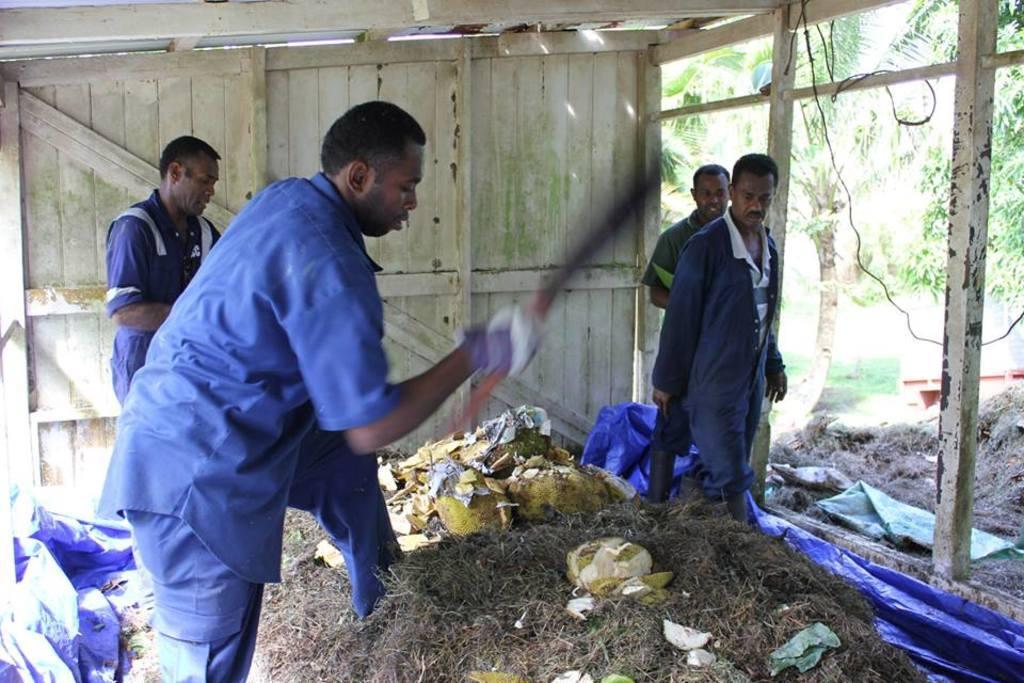Please provide a concise description of this image. In this image persons are standing on the grass. On top of the grass there is a peel of a fruit. At the back side there is a door. At the right side of the image there are trees. 